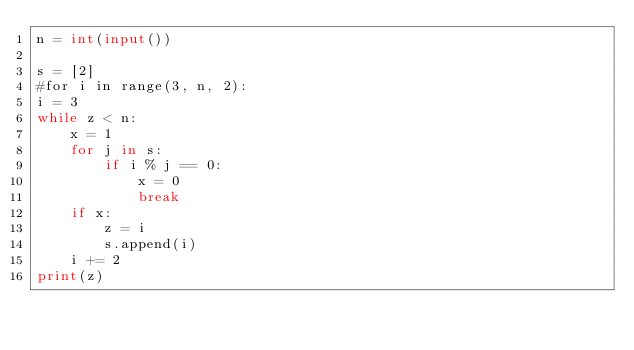<code> <loc_0><loc_0><loc_500><loc_500><_Python_>n = int(input())

s = [2]
#for i in range(3, n, 2):
i = 3
while z < n:
    x = 1
    for j in s:
        if i % j == 0:
            x = 0
            break
    if x:
        z = i
        s.append(i)
    i += 2
print(z)</code> 